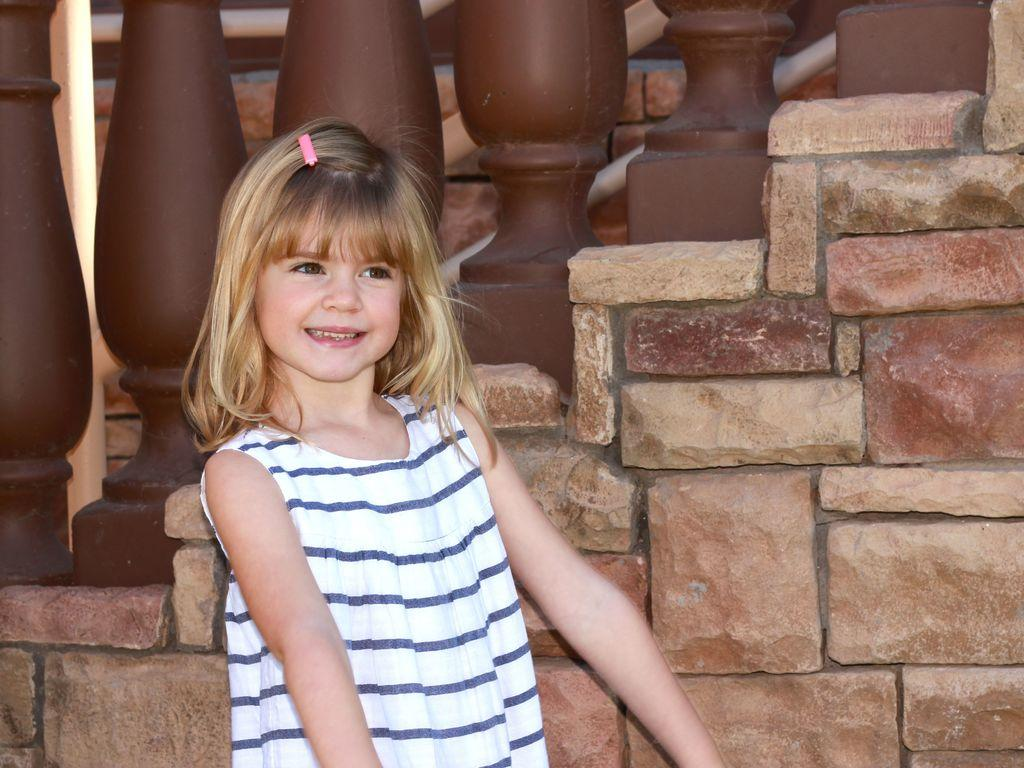Who is the main subject in the image? There is a girl in the image. What is the girl doing in the image? The girl is standing and smiling. What can be seen in the background of the image? There is a wall and railings in the background of the image. What type of sound can be heard coming from the girl in the image? There is no sound present in the image, so it cannot be determined what sound might be heard. 